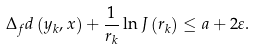Convert formula to latex. <formula><loc_0><loc_0><loc_500><loc_500>\Delta _ { f } d \left ( y _ { k } , x \right ) + \frac { 1 } { r _ { k } } \ln J \left ( r _ { k } \right ) \leq a + 2 \varepsilon .</formula> 